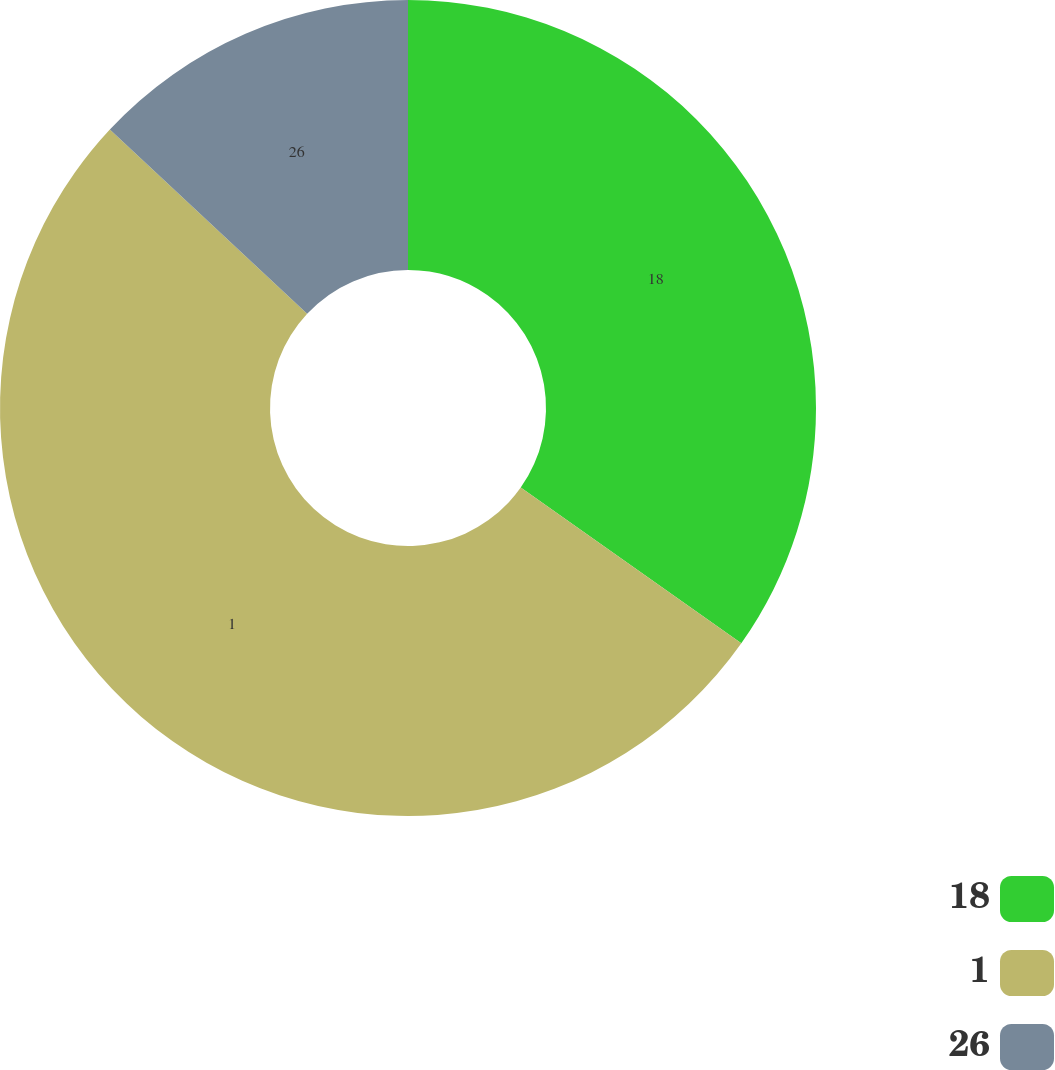<chart> <loc_0><loc_0><loc_500><loc_500><pie_chart><fcel>18<fcel>1<fcel>26<nl><fcel>34.78%<fcel>52.17%<fcel>13.04%<nl></chart> 